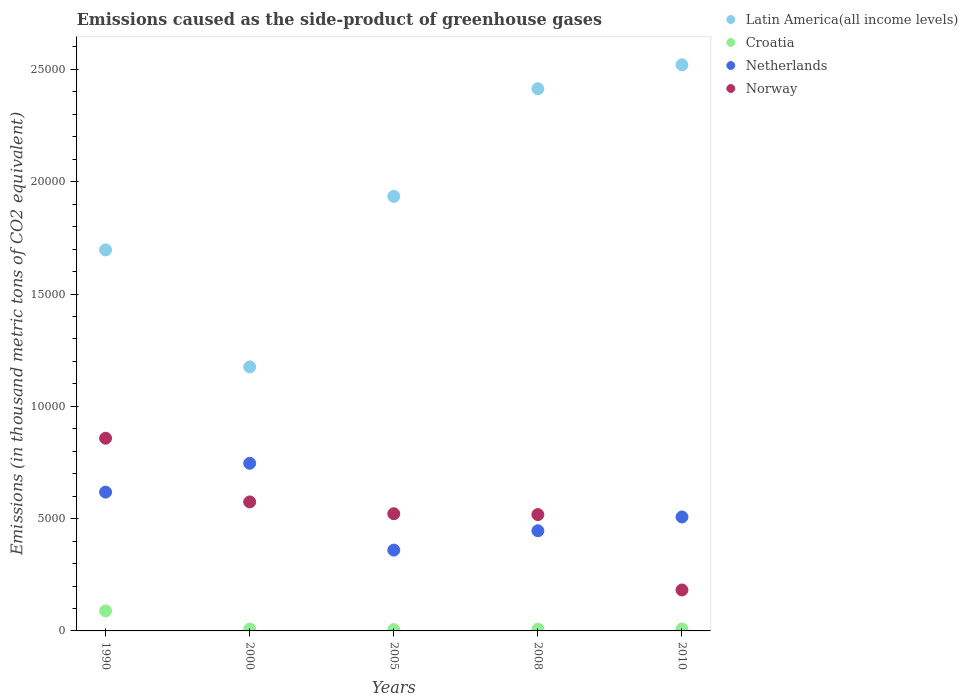Is the number of dotlines equal to the number of legend labels?
Ensure brevity in your answer.  Yes. What is the emissions caused as the side-product of greenhouse gases in Norway in 2008?
Your response must be concise. 5179.9. Across all years, what is the maximum emissions caused as the side-product of greenhouse gases in Croatia?
Make the answer very short. 890.4. Across all years, what is the minimum emissions caused as the side-product of greenhouse gases in Croatia?
Offer a terse response. 58.4. What is the total emissions caused as the side-product of greenhouse gases in Croatia in the graph?
Provide a short and direct response. 1194.4. What is the difference between the emissions caused as the side-product of greenhouse gases in Norway in 2000 and that in 2010?
Keep it short and to the point. 3919.8. What is the difference between the emissions caused as the side-product of greenhouse gases in Netherlands in 1990 and the emissions caused as the side-product of greenhouse gases in Norway in 2008?
Ensure brevity in your answer.  1000.5. What is the average emissions caused as the side-product of greenhouse gases in Latin America(all income levels) per year?
Provide a succinct answer. 1.95e+04. In the year 1990, what is the difference between the emissions caused as the side-product of greenhouse gases in Latin America(all income levels) and emissions caused as the side-product of greenhouse gases in Netherlands?
Offer a terse response. 1.08e+04. In how many years, is the emissions caused as the side-product of greenhouse gases in Norway greater than 7000 thousand metric tons?
Offer a very short reply. 1. What is the ratio of the emissions caused as the side-product of greenhouse gases in Latin America(all income levels) in 2005 to that in 2008?
Make the answer very short. 0.8. What is the difference between the highest and the second highest emissions caused as the side-product of greenhouse gases in Norway?
Your answer should be compact. 2836.5. What is the difference between the highest and the lowest emissions caused as the side-product of greenhouse gases in Croatia?
Ensure brevity in your answer.  832. Is the sum of the emissions caused as the side-product of greenhouse gases in Norway in 1990 and 2008 greater than the maximum emissions caused as the side-product of greenhouse gases in Croatia across all years?
Make the answer very short. Yes. Is it the case that in every year, the sum of the emissions caused as the side-product of greenhouse gases in Norway and emissions caused as the side-product of greenhouse gases in Latin America(all income levels)  is greater than the sum of emissions caused as the side-product of greenhouse gases in Netherlands and emissions caused as the side-product of greenhouse gases in Croatia?
Offer a very short reply. Yes. Is the emissions caused as the side-product of greenhouse gases in Latin America(all income levels) strictly greater than the emissions caused as the side-product of greenhouse gases in Norway over the years?
Offer a terse response. Yes. How many dotlines are there?
Offer a terse response. 4. What is the difference between two consecutive major ticks on the Y-axis?
Make the answer very short. 5000. Does the graph contain any zero values?
Your answer should be compact. No. Where does the legend appear in the graph?
Your answer should be compact. Top right. How many legend labels are there?
Offer a very short reply. 4. What is the title of the graph?
Keep it short and to the point. Emissions caused as the side-product of greenhouse gases. Does "South Sudan" appear as one of the legend labels in the graph?
Give a very brief answer. No. What is the label or title of the Y-axis?
Offer a very short reply. Emissions (in thousand metric tons of CO2 equivalent). What is the Emissions (in thousand metric tons of CO2 equivalent) in Latin America(all income levels) in 1990?
Make the answer very short. 1.70e+04. What is the Emissions (in thousand metric tons of CO2 equivalent) of Croatia in 1990?
Give a very brief answer. 890.4. What is the Emissions (in thousand metric tons of CO2 equivalent) of Netherlands in 1990?
Provide a short and direct response. 6180.4. What is the Emissions (in thousand metric tons of CO2 equivalent) of Norway in 1990?
Provide a succinct answer. 8579.3. What is the Emissions (in thousand metric tons of CO2 equivalent) of Latin America(all income levels) in 2000?
Make the answer very short. 1.18e+04. What is the Emissions (in thousand metric tons of CO2 equivalent) in Croatia in 2000?
Make the answer very short. 79.3. What is the Emissions (in thousand metric tons of CO2 equivalent) of Netherlands in 2000?
Make the answer very short. 7462.9. What is the Emissions (in thousand metric tons of CO2 equivalent) of Norway in 2000?
Your answer should be compact. 5742.8. What is the Emissions (in thousand metric tons of CO2 equivalent) of Latin America(all income levels) in 2005?
Make the answer very short. 1.93e+04. What is the Emissions (in thousand metric tons of CO2 equivalent) in Croatia in 2005?
Make the answer very short. 58.4. What is the Emissions (in thousand metric tons of CO2 equivalent) in Netherlands in 2005?
Offer a terse response. 3597.8. What is the Emissions (in thousand metric tons of CO2 equivalent) in Norway in 2005?
Make the answer very short. 5218.5. What is the Emissions (in thousand metric tons of CO2 equivalent) in Latin America(all income levels) in 2008?
Offer a very short reply. 2.41e+04. What is the Emissions (in thousand metric tons of CO2 equivalent) of Croatia in 2008?
Your answer should be very brief. 77.3. What is the Emissions (in thousand metric tons of CO2 equivalent) in Netherlands in 2008?
Ensure brevity in your answer.  4459.4. What is the Emissions (in thousand metric tons of CO2 equivalent) of Norway in 2008?
Offer a terse response. 5179.9. What is the Emissions (in thousand metric tons of CO2 equivalent) in Latin America(all income levels) in 2010?
Your answer should be very brief. 2.52e+04. What is the Emissions (in thousand metric tons of CO2 equivalent) of Croatia in 2010?
Keep it short and to the point. 89. What is the Emissions (in thousand metric tons of CO2 equivalent) of Netherlands in 2010?
Your response must be concise. 5074. What is the Emissions (in thousand metric tons of CO2 equivalent) in Norway in 2010?
Ensure brevity in your answer.  1823. Across all years, what is the maximum Emissions (in thousand metric tons of CO2 equivalent) of Latin America(all income levels)?
Ensure brevity in your answer.  2.52e+04. Across all years, what is the maximum Emissions (in thousand metric tons of CO2 equivalent) in Croatia?
Make the answer very short. 890.4. Across all years, what is the maximum Emissions (in thousand metric tons of CO2 equivalent) of Netherlands?
Give a very brief answer. 7462.9. Across all years, what is the maximum Emissions (in thousand metric tons of CO2 equivalent) in Norway?
Provide a short and direct response. 8579.3. Across all years, what is the minimum Emissions (in thousand metric tons of CO2 equivalent) in Latin America(all income levels)?
Give a very brief answer. 1.18e+04. Across all years, what is the minimum Emissions (in thousand metric tons of CO2 equivalent) in Croatia?
Ensure brevity in your answer.  58.4. Across all years, what is the minimum Emissions (in thousand metric tons of CO2 equivalent) of Netherlands?
Your answer should be compact. 3597.8. Across all years, what is the minimum Emissions (in thousand metric tons of CO2 equivalent) in Norway?
Provide a short and direct response. 1823. What is the total Emissions (in thousand metric tons of CO2 equivalent) of Latin America(all income levels) in the graph?
Ensure brevity in your answer.  9.74e+04. What is the total Emissions (in thousand metric tons of CO2 equivalent) of Croatia in the graph?
Offer a very short reply. 1194.4. What is the total Emissions (in thousand metric tons of CO2 equivalent) of Netherlands in the graph?
Your answer should be very brief. 2.68e+04. What is the total Emissions (in thousand metric tons of CO2 equivalent) of Norway in the graph?
Give a very brief answer. 2.65e+04. What is the difference between the Emissions (in thousand metric tons of CO2 equivalent) of Latin America(all income levels) in 1990 and that in 2000?
Provide a succinct answer. 5210.5. What is the difference between the Emissions (in thousand metric tons of CO2 equivalent) of Croatia in 1990 and that in 2000?
Provide a short and direct response. 811.1. What is the difference between the Emissions (in thousand metric tons of CO2 equivalent) of Netherlands in 1990 and that in 2000?
Ensure brevity in your answer.  -1282.5. What is the difference between the Emissions (in thousand metric tons of CO2 equivalent) of Norway in 1990 and that in 2000?
Offer a terse response. 2836.5. What is the difference between the Emissions (in thousand metric tons of CO2 equivalent) in Latin America(all income levels) in 1990 and that in 2005?
Offer a terse response. -2380.3. What is the difference between the Emissions (in thousand metric tons of CO2 equivalent) in Croatia in 1990 and that in 2005?
Give a very brief answer. 832. What is the difference between the Emissions (in thousand metric tons of CO2 equivalent) of Netherlands in 1990 and that in 2005?
Keep it short and to the point. 2582.6. What is the difference between the Emissions (in thousand metric tons of CO2 equivalent) of Norway in 1990 and that in 2005?
Make the answer very short. 3360.8. What is the difference between the Emissions (in thousand metric tons of CO2 equivalent) of Latin America(all income levels) in 1990 and that in 2008?
Your answer should be very brief. -7173.6. What is the difference between the Emissions (in thousand metric tons of CO2 equivalent) in Croatia in 1990 and that in 2008?
Provide a short and direct response. 813.1. What is the difference between the Emissions (in thousand metric tons of CO2 equivalent) of Netherlands in 1990 and that in 2008?
Your response must be concise. 1721. What is the difference between the Emissions (in thousand metric tons of CO2 equivalent) of Norway in 1990 and that in 2008?
Make the answer very short. 3399.4. What is the difference between the Emissions (in thousand metric tons of CO2 equivalent) in Latin America(all income levels) in 1990 and that in 2010?
Ensure brevity in your answer.  -8239.2. What is the difference between the Emissions (in thousand metric tons of CO2 equivalent) in Croatia in 1990 and that in 2010?
Provide a succinct answer. 801.4. What is the difference between the Emissions (in thousand metric tons of CO2 equivalent) of Netherlands in 1990 and that in 2010?
Give a very brief answer. 1106.4. What is the difference between the Emissions (in thousand metric tons of CO2 equivalent) in Norway in 1990 and that in 2010?
Your answer should be compact. 6756.3. What is the difference between the Emissions (in thousand metric tons of CO2 equivalent) of Latin America(all income levels) in 2000 and that in 2005?
Provide a short and direct response. -7590.8. What is the difference between the Emissions (in thousand metric tons of CO2 equivalent) of Croatia in 2000 and that in 2005?
Ensure brevity in your answer.  20.9. What is the difference between the Emissions (in thousand metric tons of CO2 equivalent) of Netherlands in 2000 and that in 2005?
Give a very brief answer. 3865.1. What is the difference between the Emissions (in thousand metric tons of CO2 equivalent) of Norway in 2000 and that in 2005?
Your answer should be very brief. 524.3. What is the difference between the Emissions (in thousand metric tons of CO2 equivalent) in Latin America(all income levels) in 2000 and that in 2008?
Provide a succinct answer. -1.24e+04. What is the difference between the Emissions (in thousand metric tons of CO2 equivalent) of Netherlands in 2000 and that in 2008?
Provide a short and direct response. 3003.5. What is the difference between the Emissions (in thousand metric tons of CO2 equivalent) in Norway in 2000 and that in 2008?
Keep it short and to the point. 562.9. What is the difference between the Emissions (in thousand metric tons of CO2 equivalent) of Latin America(all income levels) in 2000 and that in 2010?
Your response must be concise. -1.34e+04. What is the difference between the Emissions (in thousand metric tons of CO2 equivalent) in Netherlands in 2000 and that in 2010?
Make the answer very short. 2388.9. What is the difference between the Emissions (in thousand metric tons of CO2 equivalent) in Norway in 2000 and that in 2010?
Offer a terse response. 3919.8. What is the difference between the Emissions (in thousand metric tons of CO2 equivalent) of Latin America(all income levels) in 2005 and that in 2008?
Your answer should be very brief. -4793.3. What is the difference between the Emissions (in thousand metric tons of CO2 equivalent) of Croatia in 2005 and that in 2008?
Give a very brief answer. -18.9. What is the difference between the Emissions (in thousand metric tons of CO2 equivalent) in Netherlands in 2005 and that in 2008?
Ensure brevity in your answer.  -861.6. What is the difference between the Emissions (in thousand metric tons of CO2 equivalent) of Norway in 2005 and that in 2008?
Give a very brief answer. 38.6. What is the difference between the Emissions (in thousand metric tons of CO2 equivalent) in Latin America(all income levels) in 2005 and that in 2010?
Provide a short and direct response. -5858.9. What is the difference between the Emissions (in thousand metric tons of CO2 equivalent) in Croatia in 2005 and that in 2010?
Your response must be concise. -30.6. What is the difference between the Emissions (in thousand metric tons of CO2 equivalent) of Netherlands in 2005 and that in 2010?
Make the answer very short. -1476.2. What is the difference between the Emissions (in thousand metric tons of CO2 equivalent) in Norway in 2005 and that in 2010?
Offer a very short reply. 3395.5. What is the difference between the Emissions (in thousand metric tons of CO2 equivalent) of Latin America(all income levels) in 2008 and that in 2010?
Your response must be concise. -1065.6. What is the difference between the Emissions (in thousand metric tons of CO2 equivalent) in Croatia in 2008 and that in 2010?
Your answer should be compact. -11.7. What is the difference between the Emissions (in thousand metric tons of CO2 equivalent) of Netherlands in 2008 and that in 2010?
Ensure brevity in your answer.  -614.6. What is the difference between the Emissions (in thousand metric tons of CO2 equivalent) in Norway in 2008 and that in 2010?
Offer a very short reply. 3356.9. What is the difference between the Emissions (in thousand metric tons of CO2 equivalent) of Latin America(all income levels) in 1990 and the Emissions (in thousand metric tons of CO2 equivalent) of Croatia in 2000?
Offer a terse response. 1.69e+04. What is the difference between the Emissions (in thousand metric tons of CO2 equivalent) of Latin America(all income levels) in 1990 and the Emissions (in thousand metric tons of CO2 equivalent) of Netherlands in 2000?
Give a very brief answer. 9502.9. What is the difference between the Emissions (in thousand metric tons of CO2 equivalent) of Latin America(all income levels) in 1990 and the Emissions (in thousand metric tons of CO2 equivalent) of Norway in 2000?
Provide a short and direct response. 1.12e+04. What is the difference between the Emissions (in thousand metric tons of CO2 equivalent) in Croatia in 1990 and the Emissions (in thousand metric tons of CO2 equivalent) in Netherlands in 2000?
Your answer should be very brief. -6572.5. What is the difference between the Emissions (in thousand metric tons of CO2 equivalent) in Croatia in 1990 and the Emissions (in thousand metric tons of CO2 equivalent) in Norway in 2000?
Provide a succinct answer. -4852.4. What is the difference between the Emissions (in thousand metric tons of CO2 equivalent) of Netherlands in 1990 and the Emissions (in thousand metric tons of CO2 equivalent) of Norway in 2000?
Offer a terse response. 437.6. What is the difference between the Emissions (in thousand metric tons of CO2 equivalent) in Latin America(all income levels) in 1990 and the Emissions (in thousand metric tons of CO2 equivalent) in Croatia in 2005?
Your answer should be very brief. 1.69e+04. What is the difference between the Emissions (in thousand metric tons of CO2 equivalent) of Latin America(all income levels) in 1990 and the Emissions (in thousand metric tons of CO2 equivalent) of Netherlands in 2005?
Your response must be concise. 1.34e+04. What is the difference between the Emissions (in thousand metric tons of CO2 equivalent) of Latin America(all income levels) in 1990 and the Emissions (in thousand metric tons of CO2 equivalent) of Norway in 2005?
Ensure brevity in your answer.  1.17e+04. What is the difference between the Emissions (in thousand metric tons of CO2 equivalent) in Croatia in 1990 and the Emissions (in thousand metric tons of CO2 equivalent) in Netherlands in 2005?
Ensure brevity in your answer.  -2707.4. What is the difference between the Emissions (in thousand metric tons of CO2 equivalent) in Croatia in 1990 and the Emissions (in thousand metric tons of CO2 equivalent) in Norway in 2005?
Offer a terse response. -4328.1. What is the difference between the Emissions (in thousand metric tons of CO2 equivalent) in Netherlands in 1990 and the Emissions (in thousand metric tons of CO2 equivalent) in Norway in 2005?
Keep it short and to the point. 961.9. What is the difference between the Emissions (in thousand metric tons of CO2 equivalent) in Latin America(all income levels) in 1990 and the Emissions (in thousand metric tons of CO2 equivalent) in Croatia in 2008?
Provide a succinct answer. 1.69e+04. What is the difference between the Emissions (in thousand metric tons of CO2 equivalent) in Latin America(all income levels) in 1990 and the Emissions (in thousand metric tons of CO2 equivalent) in Netherlands in 2008?
Provide a short and direct response. 1.25e+04. What is the difference between the Emissions (in thousand metric tons of CO2 equivalent) of Latin America(all income levels) in 1990 and the Emissions (in thousand metric tons of CO2 equivalent) of Norway in 2008?
Keep it short and to the point. 1.18e+04. What is the difference between the Emissions (in thousand metric tons of CO2 equivalent) of Croatia in 1990 and the Emissions (in thousand metric tons of CO2 equivalent) of Netherlands in 2008?
Your answer should be compact. -3569. What is the difference between the Emissions (in thousand metric tons of CO2 equivalent) of Croatia in 1990 and the Emissions (in thousand metric tons of CO2 equivalent) of Norway in 2008?
Provide a succinct answer. -4289.5. What is the difference between the Emissions (in thousand metric tons of CO2 equivalent) in Netherlands in 1990 and the Emissions (in thousand metric tons of CO2 equivalent) in Norway in 2008?
Your response must be concise. 1000.5. What is the difference between the Emissions (in thousand metric tons of CO2 equivalent) of Latin America(all income levels) in 1990 and the Emissions (in thousand metric tons of CO2 equivalent) of Croatia in 2010?
Your response must be concise. 1.69e+04. What is the difference between the Emissions (in thousand metric tons of CO2 equivalent) of Latin America(all income levels) in 1990 and the Emissions (in thousand metric tons of CO2 equivalent) of Netherlands in 2010?
Your response must be concise. 1.19e+04. What is the difference between the Emissions (in thousand metric tons of CO2 equivalent) of Latin America(all income levels) in 1990 and the Emissions (in thousand metric tons of CO2 equivalent) of Norway in 2010?
Your answer should be very brief. 1.51e+04. What is the difference between the Emissions (in thousand metric tons of CO2 equivalent) in Croatia in 1990 and the Emissions (in thousand metric tons of CO2 equivalent) in Netherlands in 2010?
Offer a very short reply. -4183.6. What is the difference between the Emissions (in thousand metric tons of CO2 equivalent) of Croatia in 1990 and the Emissions (in thousand metric tons of CO2 equivalent) of Norway in 2010?
Provide a succinct answer. -932.6. What is the difference between the Emissions (in thousand metric tons of CO2 equivalent) of Netherlands in 1990 and the Emissions (in thousand metric tons of CO2 equivalent) of Norway in 2010?
Offer a very short reply. 4357.4. What is the difference between the Emissions (in thousand metric tons of CO2 equivalent) in Latin America(all income levels) in 2000 and the Emissions (in thousand metric tons of CO2 equivalent) in Croatia in 2005?
Your answer should be very brief. 1.17e+04. What is the difference between the Emissions (in thousand metric tons of CO2 equivalent) in Latin America(all income levels) in 2000 and the Emissions (in thousand metric tons of CO2 equivalent) in Netherlands in 2005?
Your answer should be compact. 8157.5. What is the difference between the Emissions (in thousand metric tons of CO2 equivalent) in Latin America(all income levels) in 2000 and the Emissions (in thousand metric tons of CO2 equivalent) in Norway in 2005?
Your answer should be very brief. 6536.8. What is the difference between the Emissions (in thousand metric tons of CO2 equivalent) in Croatia in 2000 and the Emissions (in thousand metric tons of CO2 equivalent) in Netherlands in 2005?
Your answer should be very brief. -3518.5. What is the difference between the Emissions (in thousand metric tons of CO2 equivalent) of Croatia in 2000 and the Emissions (in thousand metric tons of CO2 equivalent) of Norway in 2005?
Provide a succinct answer. -5139.2. What is the difference between the Emissions (in thousand metric tons of CO2 equivalent) of Netherlands in 2000 and the Emissions (in thousand metric tons of CO2 equivalent) of Norway in 2005?
Offer a very short reply. 2244.4. What is the difference between the Emissions (in thousand metric tons of CO2 equivalent) in Latin America(all income levels) in 2000 and the Emissions (in thousand metric tons of CO2 equivalent) in Croatia in 2008?
Make the answer very short. 1.17e+04. What is the difference between the Emissions (in thousand metric tons of CO2 equivalent) of Latin America(all income levels) in 2000 and the Emissions (in thousand metric tons of CO2 equivalent) of Netherlands in 2008?
Make the answer very short. 7295.9. What is the difference between the Emissions (in thousand metric tons of CO2 equivalent) in Latin America(all income levels) in 2000 and the Emissions (in thousand metric tons of CO2 equivalent) in Norway in 2008?
Provide a short and direct response. 6575.4. What is the difference between the Emissions (in thousand metric tons of CO2 equivalent) of Croatia in 2000 and the Emissions (in thousand metric tons of CO2 equivalent) of Netherlands in 2008?
Keep it short and to the point. -4380.1. What is the difference between the Emissions (in thousand metric tons of CO2 equivalent) of Croatia in 2000 and the Emissions (in thousand metric tons of CO2 equivalent) of Norway in 2008?
Make the answer very short. -5100.6. What is the difference between the Emissions (in thousand metric tons of CO2 equivalent) of Netherlands in 2000 and the Emissions (in thousand metric tons of CO2 equivalent) of Norway in 2008?
Your answer should be compact. 2283. What is the difference between the Emissions (in thousand metric tons of CO2 equivalent) of Latin America(all income levels) in 2000 and the Emissions (in thousand metric tons of CO2 equivalent) of Croatia in 2010?
Give a very brief answer. 1.17e+04. What is the difference between the Emissions (in thousand metric tons of CO2 equivalent) in Latin America(all income levels) in 2000 and the Emissions (in thousand metric tons of CO2 equivalent) in Netherlands in 2010?
Provide a succinct answer. 6681.3. What is the difference between the Emissions (in thousand metric tons of CO2 equivalent) of Latin America(all income levels) in 2000 and the Emissions (in thousand metric tons of CO2 equivalent) of Norway in 2010?
Your answer should be very brief. 9932.3. What is the difference between the Emissions (in thousand metric tons of CO2 equivalent) of Croatia in 2000 and the Emissions (in thousand metric tons of CO2 equivalent) of Netherlands in 2010?
Your answer should be compact. -4994.7. What is the difference between the Emissions (in thousand metric tons of CO2 equivalent) of Croatia in 2000 and the Emissions (in thousand metric tons of CO2 equivalent) of Norway in 2010?
Provide a short and direct response. -1743.7. What is the difference between the Emissions (in thousand metric tons of CO2 equivalent) of Netherlands in 2000 and the Emissions (in thousand metric tons of CO2 equivalent) of Norway in 2010?
Ensure brevity in your answer.  5639.9. What is the difference between the Emissions (in thousand metric tons of CO2 equivalent) in Latin America(all income levels) in 2005 and the Emissions (in thousand metric tons of CO2 equivalent) in Croatia in 2008?
Make the answer very short. 1.93e+04. What is the difference between the Emissions (in thousand metric tons of CO2 equivalent) of Latin America(all income levels) in 2005 and the Emissions (in thousand metric tons of CO2 equivalent) of Netherlands in 2008?
Offer a terse response. 1.49e+04. What is the difference between the Emissions (in thousand metric tons of CO2 equivalent) in Latin America(all income levels) in 2005 and the Emissions (in thousand metric tons of CO2 equivalent) in Norway in 2008?
Your response must be concise. 1.42e+04. What is the difference between the Emissions (in thousand metric tons of CO2 equivalent) of Croatia in 2005 and the Emissions (in thousand metric tons of CO2 equivalent) of Netherlands in 2008?
Give a very brief answer. -4401. What is the difference between the Emissions (in thousand metric tons of CO2 equivalent) in Croatia in 2005 and the Emissions (in thousand metric tons of CO2 equivalent) in Norway in 2008?
Ensure brevity in your answer.  -5121.5. What is the difference between the Emissions (in thousand metric tons of CO2 equivalent) of Netherlands in 2005 and the Emissions (in thousand metric tons of CO2 equivalent) of Norway in 2008?
Provide a succinct answer. -1582.1. What is the difference between the Emissions (in thousand metric tons of CO2 equivalent) in Latin America(all income levels) in 2005 and the Emissions (in thousand metric tons of CO2 equivalent) in Croatia in 2010?
Give a very brief answer. 1.93e+04. What is the difference between the Emissions (in thousand metric tons of CO2 equivalent) of Latin America(all income levels) in 2005 and the Emissions (in thousand metric tons of CO2 equivalent) of Netherlands in 2010?
Give a very brief answer. 1.43e+04. What is the difference between the Emissions (in thousand metric tons of CO2 equivalent) of Latin America(all income levels) in 2005 and the Emissions (in thousand metric tons of CO2 equivalent) of Norway in 2010?
Provide a short and direct response. 1.75e+04. What is the difference between the Emissions (in thousand metric tons of CO2 equivalent) in Croatia in 2005 and the Emissions (in thousand metric tons of CO2 equivalent) in Netherlands in 2010?
Provide a succinct answer. -5015.6. What is the difference between the Emissions (in thousand metric tons of CO2 equivalent) of Croatia in 2005 and the Emissions (in thousand metric tons of CO2 equivalent) of Norway in 2010?
Provide a succinct answer. -1764.6. What is the difference between the Emissions (in thousand metric tons of CO2 equivalent) in Netherlands in 2005 and the Emissions (in thousand metric tons of CO2 equivalent) in Norway in 2010?
Offer a terse response. 1774.8. What is the difference between the Emissions (in thousand metric tons of CO2 equivalent) in Latin America(all income levels) in 2008 and the Emissions (in thousand metric tons of CO2 equivalent) in Croatia in 2010?
Your answer should be compact. 2.41e+04. What is the difference between the Emissions (in thousand metric tons of CO2 equivalent) in Latin America(all income levels) in 2008 and the Emissions (in thousand metric tons of CO2 equivalent) in Netherlands in 2010?
Offer a terse response. 1.91e+04. What is the difference between the Emissions (in thousand metric tons of CO2 equivalent) in Latin America(all income levels) in 2008 and the Emissions (in thousand metric tons of CO2 equivalent) in Norway in 2010?
Offer a very short reply. 2.23e+04. What is the difference between the Emissions (in thousand metric tons of CO2 equivalent) of Croatia in 2008 and the Emissions (in thousand metric tons of CO2 equivalent) of Netherlands in 2010?
Give a very brief answer. -4996.7. What is the difference between the Emissions (in thousand metric tons of CO2 equivalent) in Croatia in 2008 and the Emissions (in thousand metric tons of CO2 equivalent) in Norway in 2010?
Keep it short and to the point. -1745.7. What is the difference between the Emissions (in thousand metric tons of CO2 equivalent) in Netherlands in 2008 and the Emissions (in thousand metric tons of CO2 equivalent) in Norway in 2010?
Provide a short and direct response. 2636.4. What is the average Emissions (in thousand metric tons of CO2 equivalent) in Latin America(all income levels) per year?
Make the answer very short. 1.95e+04. What is the average Emissions (in thousand metric tons of CO2 equivalent) in Croatia per year?
Your answer should be very brief. 238.88. What is the average Emissions (in thousand metric tons of CO2 equivalent) in Netherlands per year?
Give a very brief answer. 5354.9. What is the average Emissions (in thousand metric tons of CO2 equivalent) in Norway per year?
Your answer should be very brief. 5308.7. In the year 1990, what is the difference between the Emissions (in thousand metric tons of CO2 equivalent) of Latin America(all income levels) and Emissions (in thousand metric tons of CO2 equivalent) of Croatia?
Make the answer very short. 1.61e+04. In the year 1990, what is the difference between the Emissions (in thousand metric tons of CO2 equivalent) in Latin America(all income levels) and Emissions (in thousand metric tons of CO2 equivalent) in Netherlands?
Provide a short and direct response. 1.08e+04. In the year 1990, what is the difference between the Emissions (in thousand metric tons of CO2 equivalent) in Latin America(all income levels) and Emissions (in thousand metric tons of CO2 equivalent) in Norway?
Your response must be concise. 8386.5. In the year 1990, what is the difference between the Emissions (in thousand metric tons of CO2 equivalent) in Croatia and Emissions (in thousand metric tons of CO2 equivalent) in Netherlands?
Your response must be concise. -5290. In the year 1990, what is the difference between the Emissions (in thousand metric tons of CO2 equivalent) of Croatia and Emissions (in thousand metric tons of CO2 equivalent) of Norway?
Offer a very short reply. -7688.9. In the year 1990, what is the difference between the Emissions (in thousand metric tons of CO2 equivalent) in Netherlands and Emissions (in thousand metric tons of CO2 equivalent) in Norway?
Keep it short and to the point. -2398.9. In the year 2000, what is the difference between the Emissions (in thousand metric tons of CO2 equivalent) in Latin America(all income levels) and Emissions (in thousand metric tons of CO2 equivalent) in Croatia?
Keep it short and to the point. 1.17e+04. In the year 2000, what is the difference between the Emissions (in thousand metric tons of CO2 equivalent) in Latin America(all income levels) and Emissions (in thousand metric tons of CO2 equivalent) in Netherlands?
Your answer should be very brief. 4292.4. In the year 2000, what is the difference between the Emissions (in thousand metric tons of CO2 equivalent) of Latin America(all income levels) and Emissions (in thousand metric tons of CO2 equivalent) of Norway?
Keep it short and to the point. 6012.5. In the year 2000, what is the difference between the Emissions (in thousand metric tons of CO2 equivalent) of Croatia and Emissions (in thousand metric tons of CO2 equivalent) of Netherlands?
Make the answer very short. -7383.6. In the year 2000, what is the difference between the Emissions (in thousand metric tons of CO2 equivalent) in Croatia and Emissions (in thousand metric tons of CO2 equivalent) in Norway?
Provide a short and direct response. -5663.5. In the year 2000, what is the difference between the Emissions (in thousand metric tons of CO2 equivalent) in Netherlands and Emissions (in thousand metric tons of CO2 equivalent) in Norway?
Your answer should be very brief. 1720.1. In the year 2005, what is the difference between the Emissions (in thousand metric tons of CO2 equivalent) in Latin America(all income levels) and Emissions (in thousand metric tons of CO2 equivalent) in Croatia?
Your response must be concise. 1.93e+04. In the year 2005, what is the difference between the Emissions (in thousand metric tons of CO2 equivalent) of Latin America(all income levels) and Emissions (in thousand metric tons of CO2 equivalent) of Netherlands?
Offer a very short reply. 1.57e+04. In the year 2005, what is the difference between the Emissions (in thousand metric tons of CO2 equivalent) in Latin America(all income levels) and Emissions (in thousand metric tons of CO2 equivalent) in Norway?
Your answer should be very brief. 1.41e+04. In the year 2005, what is the difference between the Emissions (in thousand metric tons of CO2 equivalent) in Croatia and Emissions (in thousand metric tons of CO2 equivalent) in Netherlands?
Your response must be concise. -3539.4. In the year 2005, what is the difference between the Emissions (in thousand metric tons of CO2 equivalent) in Croatia and Emissions (in thousand metric tons of CO2 equivalent) in Norway?
Your answer should be very brief. -5160.1. In the year 2005, what is the difference between the Emissions (in thousand metric tons of CO2 equivalent) of Netherlands and Emissions (in thousand metric tons of CO2 equivalent) of Norway?
Your answer should be very brief. -1620.7. In the year 2008, what is the difference between the Emissions (in thousand metric tons of CO2 equivalent) of Latin America(all income levels) and Emissions (in thousand metric tons of CO2 equivalent) of Croatia?
Provide a succinct answer. 2.41e+04. In the year 2008, what is the difference between the Emissions (in thousand metric tons of CO2 equivalent) of Latin America(all income levels) and Emissions (in thousand metric tons of CO2 equivalent) of Netherlands?
Keep it short and to the point. 1.97e+04. In the year 2008, what is the difference between the Emissions (in thousand metric tons of CO2 equivalent) in Latin America(all income levels) and Emissions (in thousand metric tons of CO2 equivalent) in Norway?
Your answer should be compact. 1.90e+04. In the year 2008, what is the difference between the Emissions (in thousand metric tons of CO2 equivalent) of Croatia and Emissions (in thousand metric tons of CO2 equivalent) of Netherlands?
Provide a short and direct response. -4382.1. In the year 2008, what is the difference between the Emissions (in thousand metric tons of CO2 equivalent) of Croatia and Emissions (in thousand metric tons of CO2 equivalent) of Norway?
Ensure brevity in your answer.  -5102.6. In the year 2008, what is the difference between the Emissions (in thousand metric tons of CO2 equivalent) of Netherlands and Emissions (in thousand metric tons of CO2 equivalent) of Norway?
Your answer should be compact. -720.5. In the year 2010, what is the difference between the Emissions (in thousand metric tons of CO2 equivalent) of Latin America(all income levels) and Emissions (in thousand metric tons of CO2 equivalent) of Croatia?
Your answer should be very brief. 2.51e+04. In the year 2010, what is the difference between the Emissions (in thousand metric tons of CO2 equivalent) in Latin America(all income levels) and Emissions (in thousand metric tons of CO2 equivalent) in Netherlands?
Your response must be concise. 2.01e+04. In the year 2010, what is the difference between the Emissions (in thousand metric tons of CO2 equivalent) of Latin America(all income levels) and Emissions (in thousand metric tons of CO2 equivalent) of Norway?
Offer a very short reply. 2.34e+04. In the year 2010, what is the difference between the Emissions (in thousand metric tons of CO2 equivalent) of Croatia and Emissions (in thousand metric tons of CO2 equivalent) of Netherlands?
Offer a very short reply. -4985. In the year 2010, what is the difference between the Emissions (in thousand metric tons of CO2 equivalent) in Croatia and Emissions (in thousand metric tons of CO2 equivalent) in Norway?
Make the answer very short. -1734. In the year 2010, what is the difference between the Emissions (in thousand metric tons of CO2 equivalent) of Netherlands and Emissions (in thousand metric tons of CO2 equivalent) of Norway?
Offer a terse response. 3251. What is the ratio of the Emissions (in thousand metric tons of CO2 equivalent) of Latin America(all income levels) in 1990 to that in 2000?
Give a very brief answer. 1.44. What is the ratio of the Emissions (in thousand metric tons of CO2 equivalent) of Croatia in 1990 to that in 2000?
Make the answer very short. 11.23. What is the ratio of the Emissions (in thousand metric tons of CO2 equivalent) of Netherlands in 1990 to that in 2000?
Offer a terse response. 0.83. What is the ratio of the Emissions (in thousand metric tons of CO2 equivalent) of Norway in 1990 to that in 2000?
Your response must be concise. 1.49. What is the ratio of the Emissions (in thousand metric tons of CO2 equivalent) of Latin America(all income levels) in 1990 to that in 2005?
Keep it short and to the point. 0.88. What is the ratio of the Emissions (in thousand metric tons of CO2 equivalent) of Croatia in 1990 to that in 2005?
Your answer should be compact. 15.25. What is the ratio of the Emissions (in thousand metric tons of CO2 equivalent) in Netherlands in 1990 to that in 2005?
Offer a very short reply. 1.72. What is the ratio of the Emissions (in thousand metric tons of CO2 equivalent) in Norway in 1990 to that in 2005?
Ensure brevity in your answer.  1.64. What is the ratio of the Emissions (in thousand metric tons of CO2 equivalent) of Latin America(all income levels) in 1990 to that in 2008?
Ensure brevity in your answer.  0.7. What is the ratio of the Emissions (in thousand metric tons of CO2 equivalent) in Croatia in 1990 to that in 2008?
Make the answer very short. 11.52. What is the ratio of the Emissions (in thousand metric tons of CO2 equivalent) of Netherlands in 1990 to that in 2008?
Ensure brevity in your answer.  1.39. What is the ratio of the Emissions (in thousand metric tons of CO2 equivalent) in Norway in 1990 to that in 2008?
Your response must be concise. 1.66. What is the ratio of the Emissions (in thousand metric tons of CO2 equivalent) in Latin America(all income levels) in 1990 to that in 2010?
Provide a succinct answer. 0.67. What is the ratio of the Emissions (in thousand metric tons of CO2 equivalent) of Croatia in 1990 to that in 2010?
Offer a terse response. 10. What is the ratio of the Emissions (in thousand metric tons of CO2 equivalent) of Netherlands in 1990 to that in 2010?
Make the answer very short. 1.22. What is the ratio of the Emissions (in thousand metric tons of CO2 equivalent) in Norway in 1990 to that in 2010?
Provide a succinct answer. 4.71. What is the ratio of the Emissions (in thousand metric tons of CO2 equivalent) of Latin America(all income levels) in 2000 to that in 2005?
Keep it short and to the point. 0.61. What is the ratio of the Emissions (in thousand metric tons of CO2 equivalent) of Croatia in 2000 to that in 2005?
Your response must be concise. 1.36. What is the ratio of the Emissions (in thousand metric tons of CO2 equivalent) of Netherlands in 2000 to that in 2005?
Provide a succinct answer. 2.07. What is the ratio of the Emissions (in thousand metric tons of CO2 equivalent) of Norway in 2000 to that in 2005?
Offer a very short reply. 1.1. What is the ratio of the Emissions (in thousand metric tons of CO2 equivalent) in Latin America(all income levels) in 2000 to that in 2008?
Offer a very short reply. 0.49. What is the ratio of the Emissions (in thousand metric tons of CO2 equivalent) of Croatia in 2000 to that in 2008?
Make the answer very short. 1.03. What is the ratio of the Emissions (in thousand metric tons of CO2 equivalent) of Netherlands in 2000 to that in 2008?
Keep it short and to the point. 1.67. What is the ratio of the Emissions (in thousand metric tons of CO2 equivalent) of Norway in 2000 to that in 2008?
Offer a very short reply. 1.11. What is the ratio of the Emissions (in thousand metric tons of CO2 equivalent) in Latin America(all income levels) in 2000 to that in 2010?
Your response must be concise. 0.47. What is the ratio of the Emissions (in thousand metric tons of CO2 equivalent) in Croatia in 2000 to that in 2010?
Give a very brief answer. 0.89. What is the ratio of the Emissions (in thousand metric tons of CO2 equivalent) in Netherlands in 2000 to that in 2010?
Your response must be concise. 1.47. What is the ratio of the Emissions (in thousand metric tons of CO2 equivalent) of Norway in 2000 to that in 2010?
Your response must be concise. 3.15. What is the ratio of the Emissions (in thousand metric tons of CO2 equivalent) in Latin America(all income levels) in 2005 to that in 2008?
Give a very brief answer. 0.8. What is the ratio of the Emissions (in thousand metric tons of CO2 equivalent) of Croatia in 2005 to that in 2008?
Make the answer very short. 0.76. What is the ratio of the Emissions (in thousand metric tons of CO2 equivalent) of Netherlands in 2005 to that in 2008?
Your answer should be very brief. 0.81. What is the ratio of the Emissions (in thousand metric tons of CO2 equivalent) of Norway in 2005 to that in 2008?
Give a very brief answer. 1.01. What is the ratio of the Emissions (in thousand metric tons of CO2 equivalent) of Latin America(all income levels) in 2005 to that in 2010?
Your answer should be compact. 0.77. What is the ratio of the Emissions (in thousand metric tons of CO2 equivalent) of Croatia in 2005 to that in 2010?
Your response must be concise. 0.66. What is the ratio of the Emissions (in thousand metric tons of CO2 equivalent) of Netherlands in 2005 to that in 2010?
Provide a short and direct response. 0.71. What is the ratio of the Emissions (in thousand metric tons of CO2 equivalent) of Norway in 2005 to that in 2010?
Give a very brief answer. 2.86. What is the ratio of the Emissions (in thousand metric tons of CO2 equivalent) of Latin America(all income levels) in 2008 to that in 2010?
Your answer should be very brief. 0.96. What is the ratio of the Emissions (in thousand metric tons of CO2 equivalent) in Croatia in 2008 to that in 2010?
Ensure brevity in your answer.  0.87. What is the ratio of the Emissions (in thousand metric tons of CO2 equivalent) of Netherlands in 2008 to that in 2010?
Give a very brief answer. 0.88. What is the ratio of the Emissions (in thousand metric tons of CO2 equivalent) of Norway in 2008 to that in 2010?
Your answer should be compact. 2.84. What is the difference between the highest and the second highest Emissions (in thousand metric tons of CO2 equivalent) of Latin America(all income levels)?
Provide a short and direct response. 1065.6. What is the difference between the highest and the second highest Emissions (in thousand metric tons of CO2 equivalent) in Croatia?
Offer a very short reply. 801.4. What is the difference between the highest and the second highest Emissions (in thousand metric tons of CO2 equivalent) in Netherlands?
Your answer should be compact. 1282.5. What is the difference between the highest and the second highest Emissions (in thousand metric tons of CO2 equivalent) in Norway?
Make the answer very short. 2836.5. What is the difference between the highest and the lowest Emissions (in thousand metric tons of CO2 equivalent) of Latin America(all income levels)?
Provide a succinct answer. 1.34e+04. What is the difference between the highest and the lowest Emissions (in thousand metric tons of CO2 equivalent) of Croatia?
Offer a terse response. 832. What is the difference between the highest and the lowest Emissions (in thousand metric tons of CO2 equivalent) in Netherlands?
Offer a very short reply. 3865.1. What is the difference between the highest and the lowest Emissions (in thousand metric tons of CO2 equivalent) of Norway?
Your answer should be compact. 6756.3. 